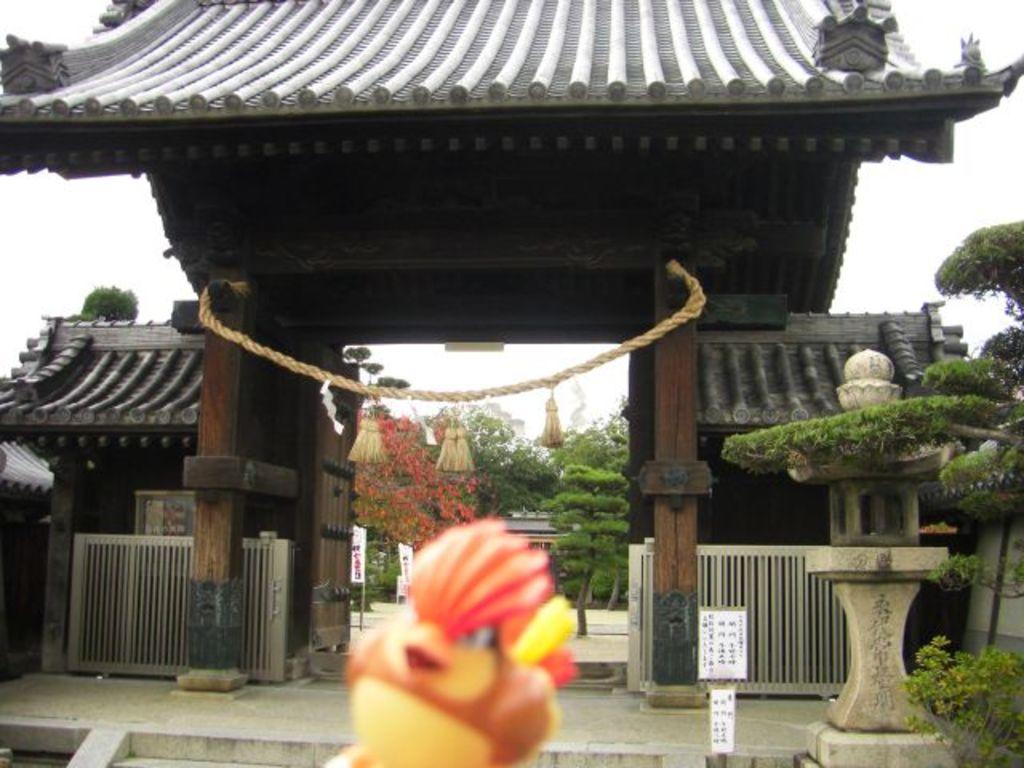Describe this image in one or two sentences. In this image I can see the toy which is in yellow and red color. In the back I can see the arch and there is a rope to it. In the back there are many trees and some flowers to it. the flowers are in red color. And I can also see the white color sky in the background. 